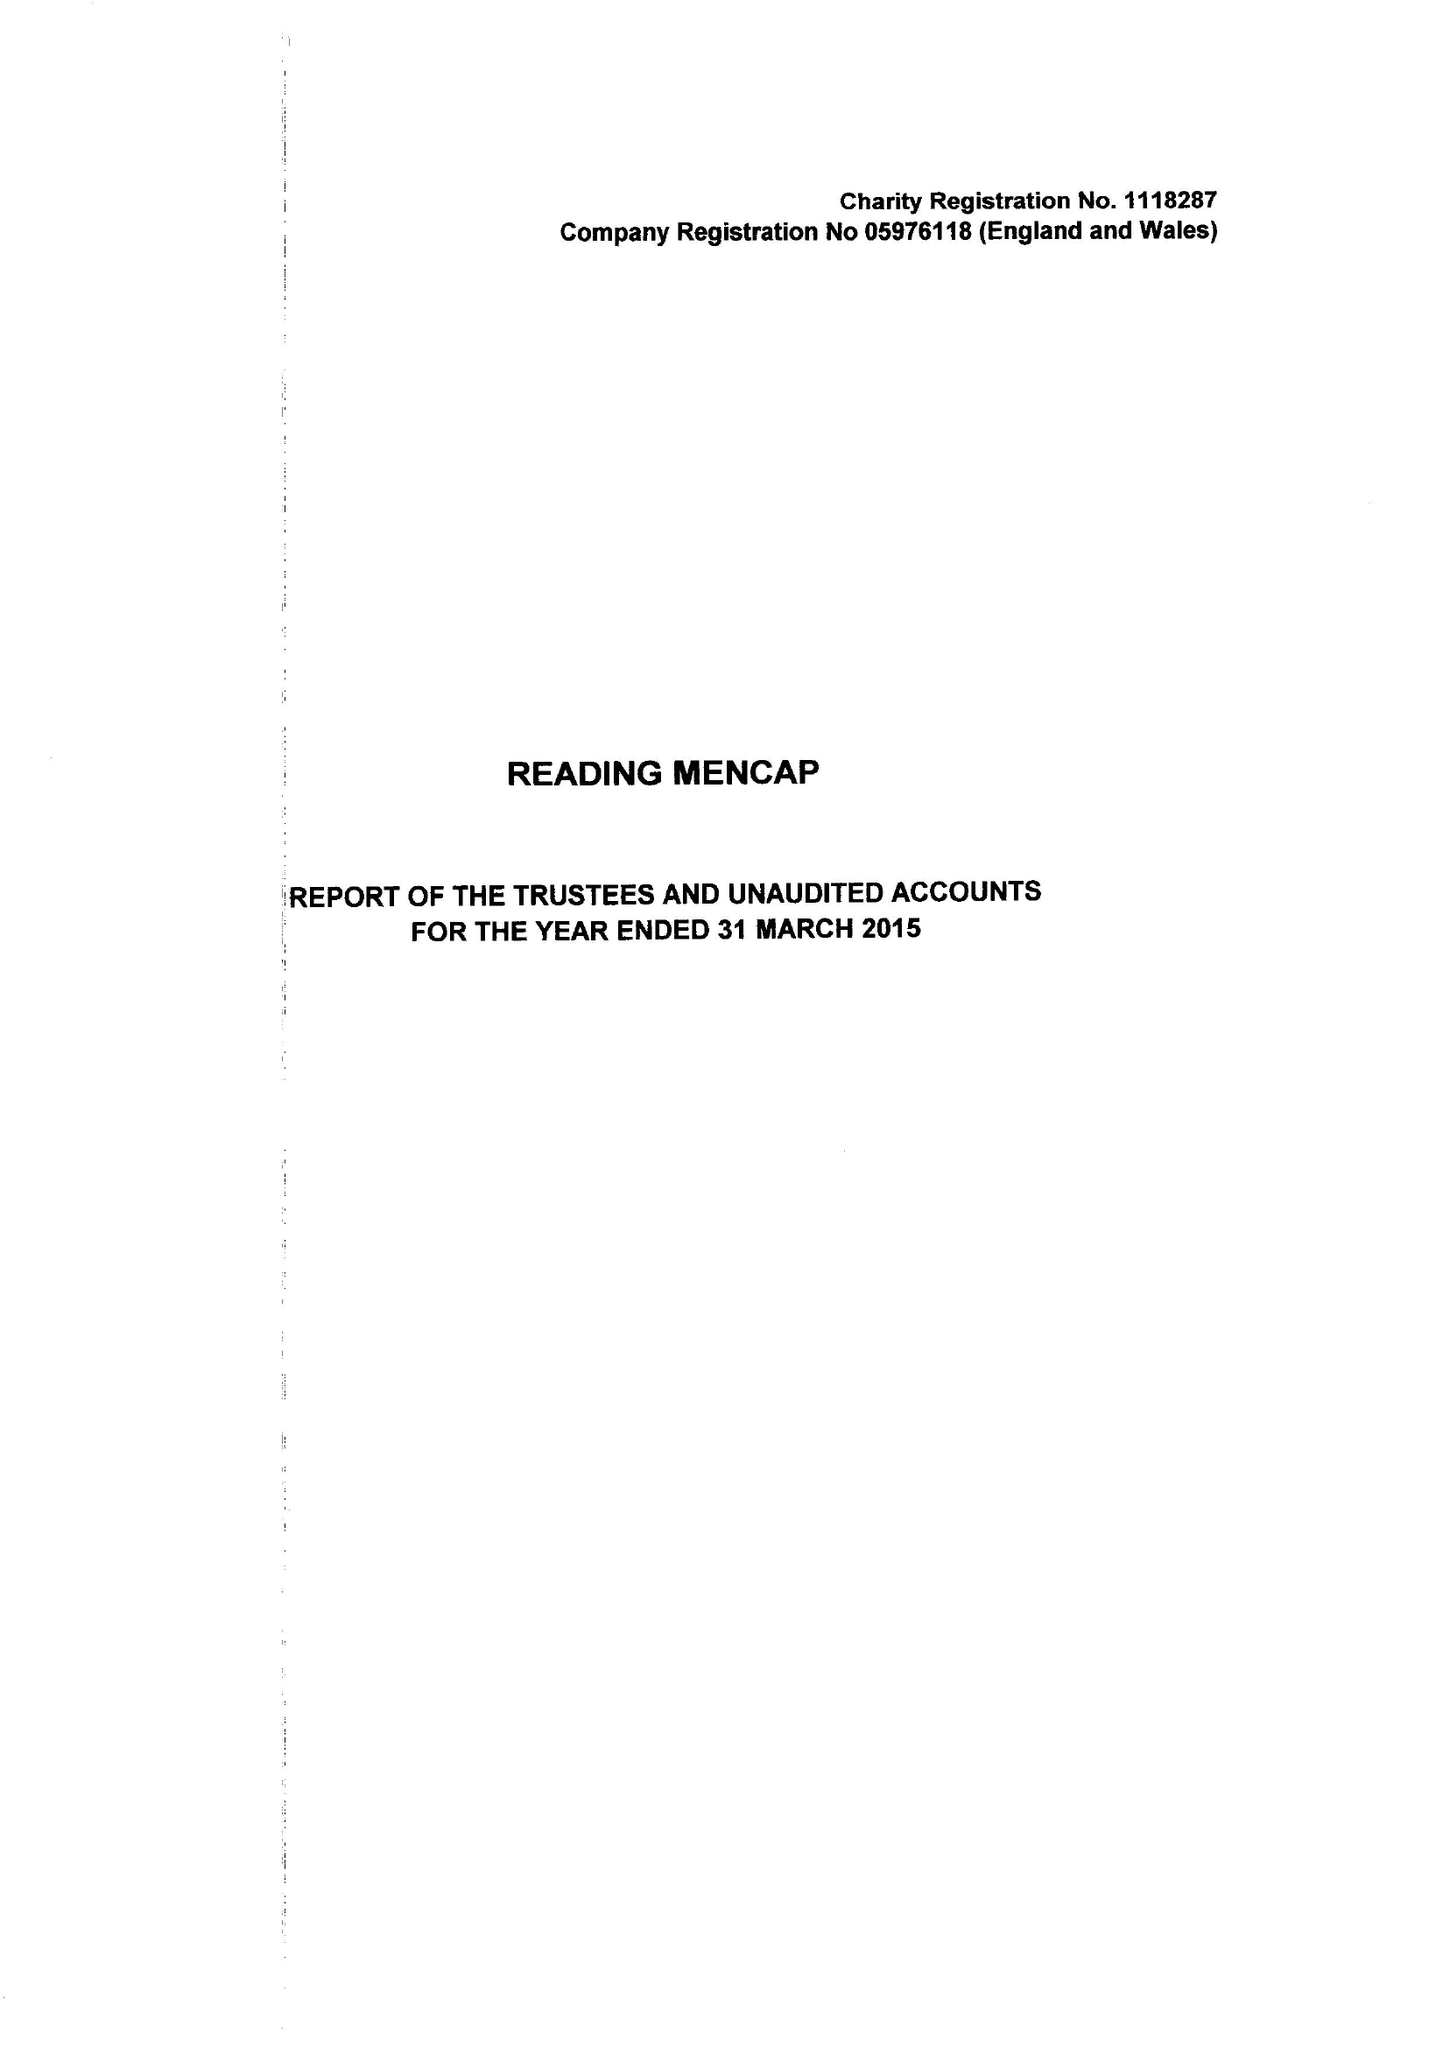What is the value for the income_annually_in_british_pounds?
Answer the question using a single word or phrase. 358947.00 